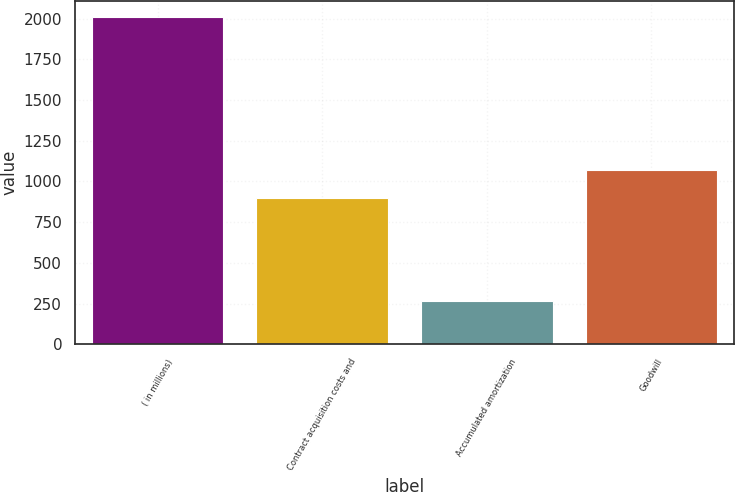<chart> <loc_0><loc_0><loc_500><loc_500><bar_chart><fcel>( in millions)<fcel>Contract acquisition costs and<fcel>Accumulated amortization<fcel>Goodwill<nl><fcel>2007<fcel>899<fcel>264<fcel>1073.3<nl></chart> 